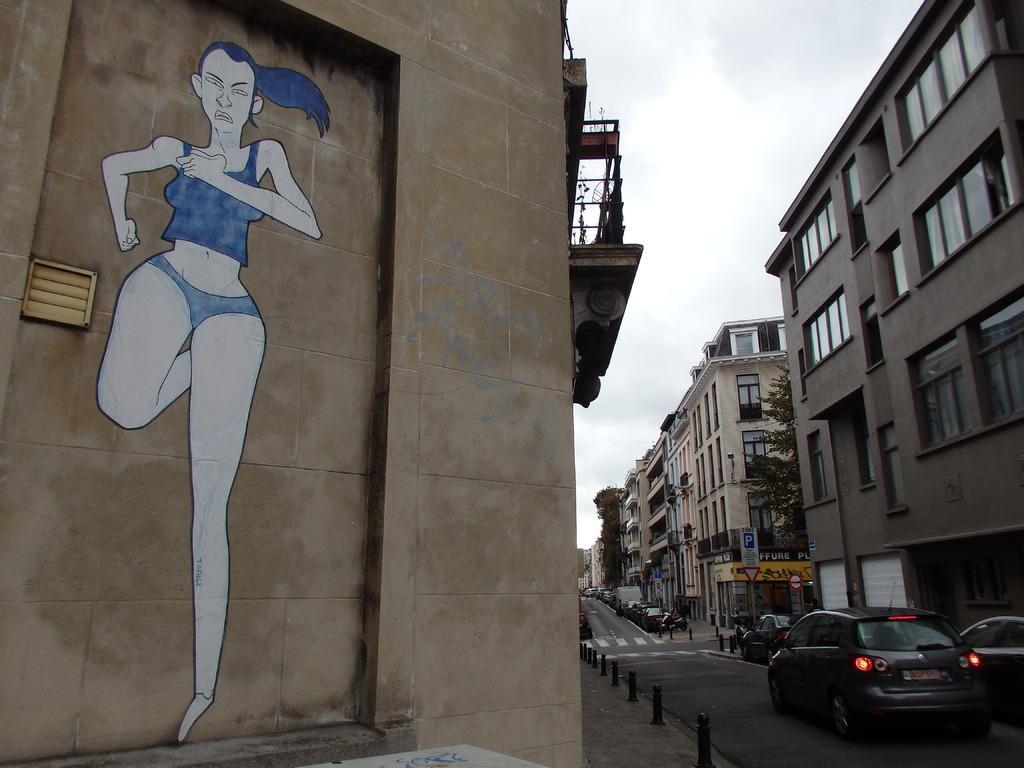In one or two sentences, can you explain what this image depicts? In this image I see number of buildings and on this wall I see the depiction of picture of a woman and I see the road on which there are number of vehicles and I see few trees. In the background I see the sky. 